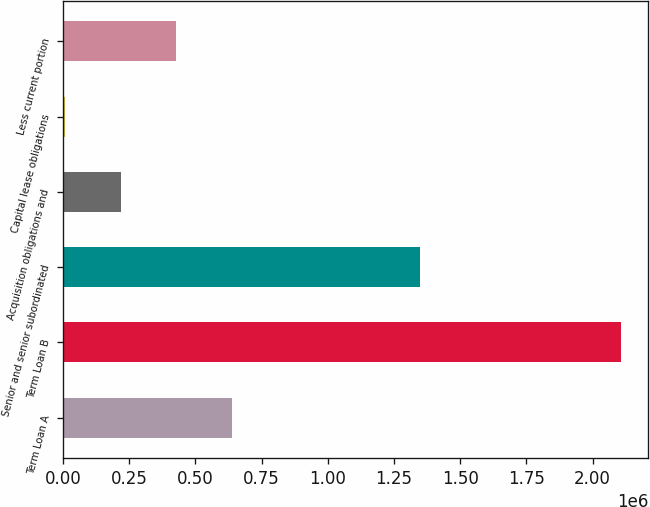Convert chart to OTSL. <chart><loc_0><loc_0><loc_500><loc_500><bar_chart><fcel>Term Loan A<fcel>Term Loan B<fcel>Senior and senior subordinated<fcel>Acquisition obligations and<fcel>Capital lease obligations<fcel>Less current portion<nl><fcel>636613<fcel>2.10588e+06<fcel>1.35e+06<fcel>216824<fcel>6929<fcel>426718<nl></chart> 